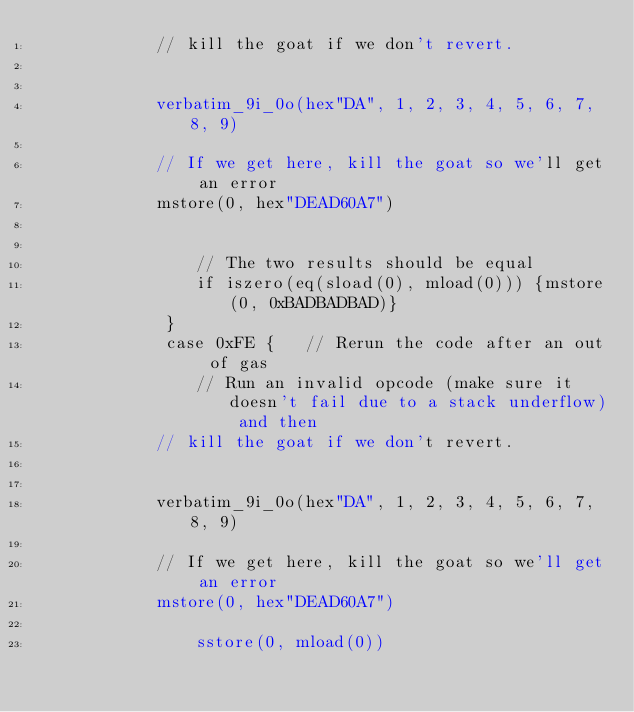<code> <loc_0><loc_0><loc_500><loc_500><_YAML_>            // kill the goat if we don't revert.
            
            
            verbatim_9i_0o(hex"DA", 1, 2, 3, 4, 5, 6, 7, 8, 9)
            
            // If we get here, kill the goat so we'll get an error
            mstore(0, hex"DEAD60A7")
            

                // The two results should be equal
                if iszero(eq(sload(0), mload(0))) {mstore(0, 0xBADBADBAD)}
             }
             case 0xFE {   // Rerun the code after an out of gas
                // Run an invalid opcode (make sure it doesn't fail due to a stack underflow) and then
            // kill the goat if we don't revert.
            
            
            verbatim_9i_0o(hex"DA", 1, 2, 3, 4, 5, 6, 7, 8, 9)
            
            // If we get here, kill the goat so we'll get an error
            mstore(0, hex"DEAD60A7")
            
                sstore(0, mload(0))
</code> 